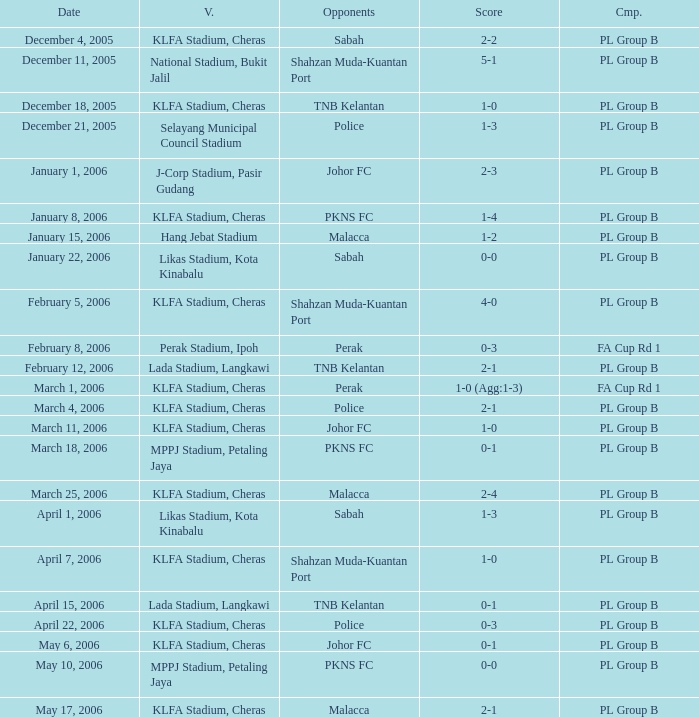Which Venue has a Competition of pl group b, and a Score of 2-2? KLFA Stadium, Cheras. 